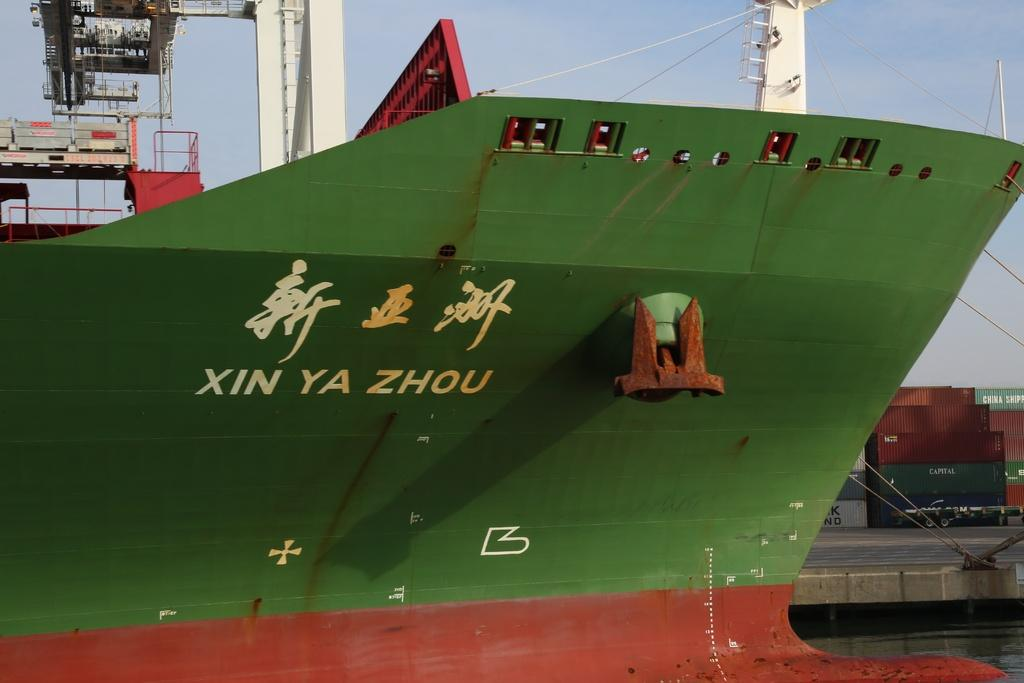What color is the ship in the image? The ship in the image is green-colored. What is written on the ship? There is text written on the ship. What can be seen in the background of the image? In the background of the image, there are wires and cargo containers visible. What is visible in the sky in the image? The sky is visible in the background of the image. How many pies are being baked on the ship in the image? There are no pies visible in the image; it features a green-colored ship with text and a background with wires and cargo containers. What type of clam is used to anchor the ship in the image? There is no clam present in the image; it features a green-colored ship with text and a background with wires and cargo containers. 